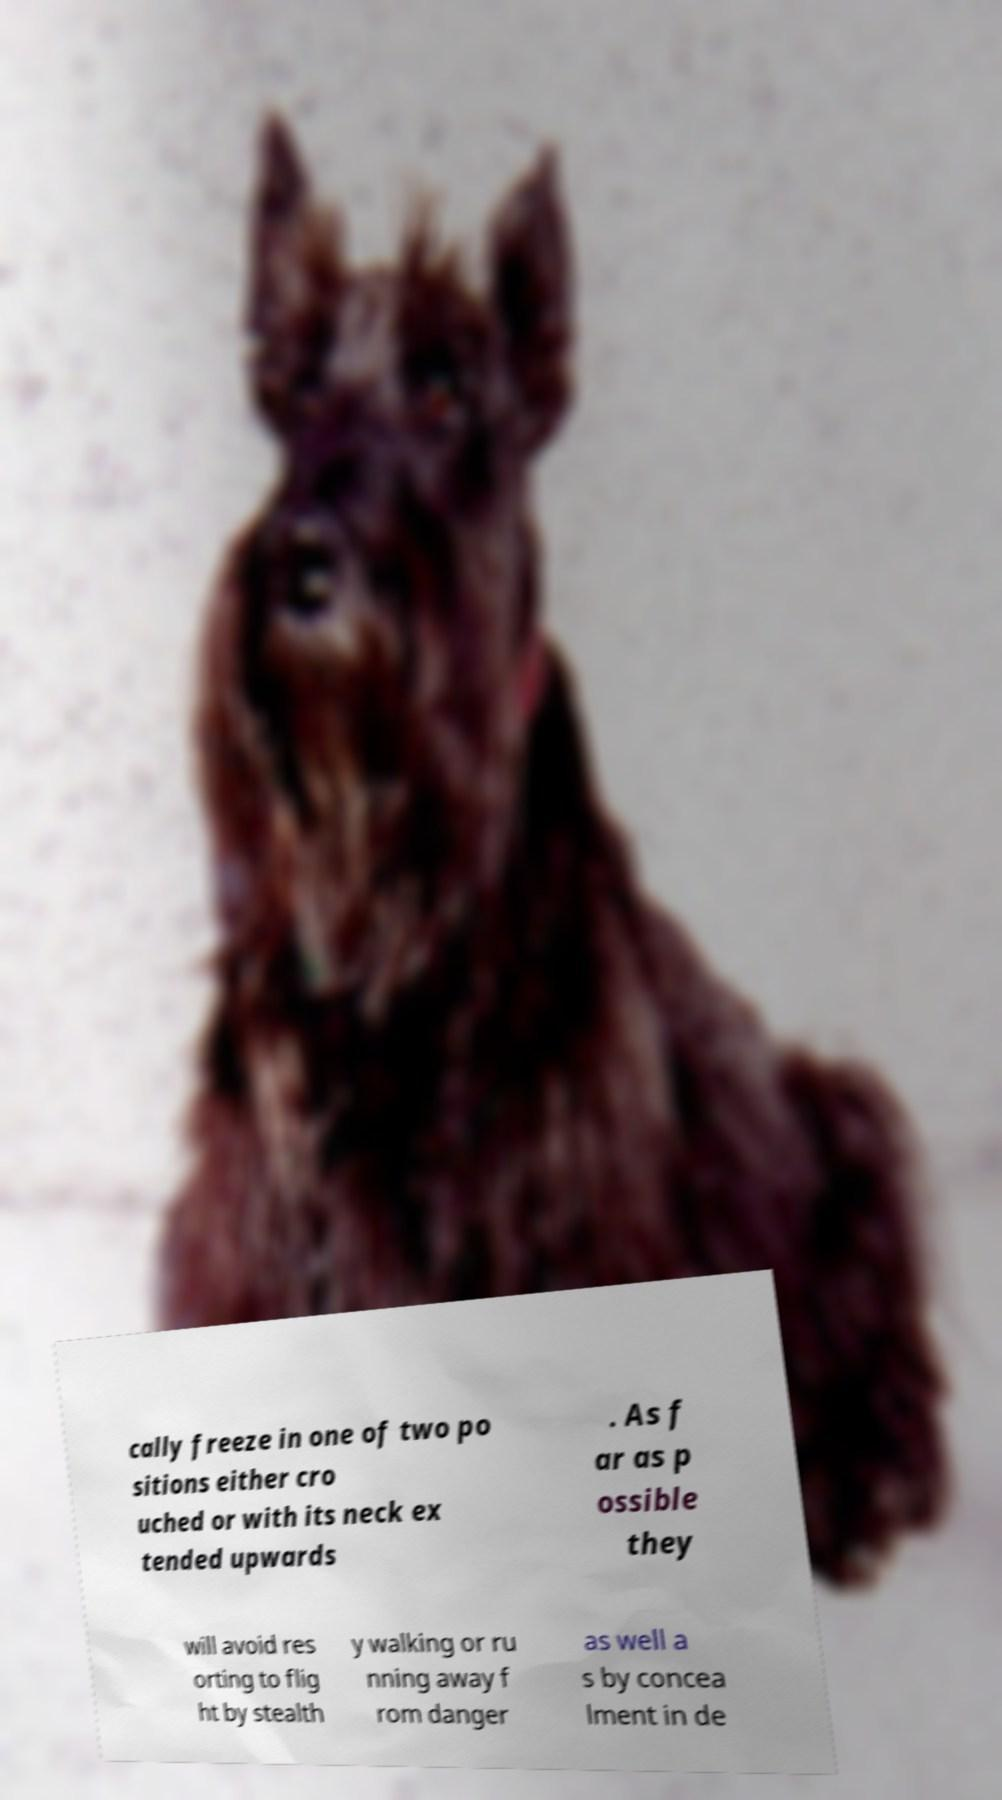Can you read and provide the text displayed in the image?This photo seems to have some interesting text. Can you extract and type it out for me? cally freeze in one of two po sitions either cro uched or with its neck ex tended upwards . As f ar as p ossible they will avoid res orting to flig ht by stealth y walking or ru nning away f rom danger as well a s by concea lment in de 